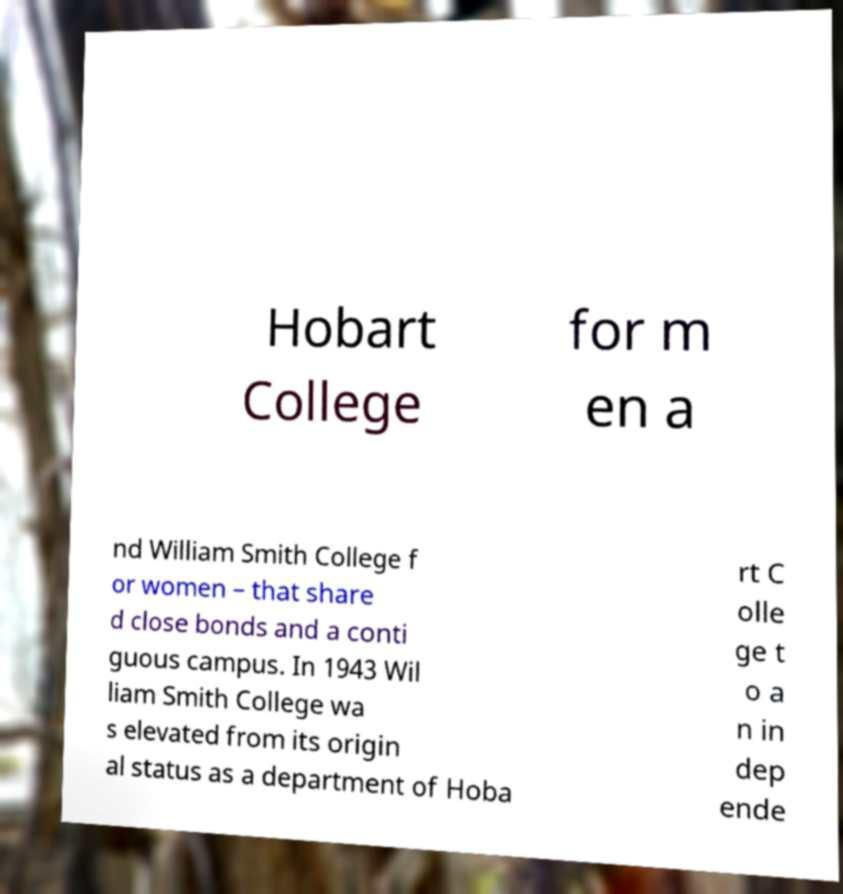For documentation purposes, I need the text within this image transcribed. Could you provide that? Hobart College for m en a nd William Smith College f or women – that share d close bonds and a conti guous campus. In 1943 Wil liam Smith College wa s elevated from its origin al status as a department of Hoba rt C olle ge t o a n in dep ende 